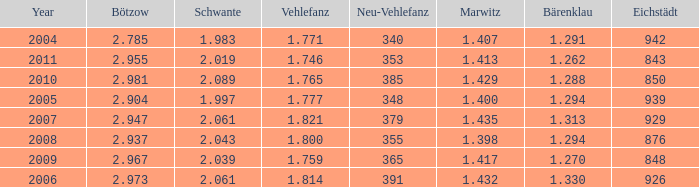What year has a Schwante smaller than 2.043, an Eichstädt smaller than 848, and a Bärenklau smaller than 1.262? 0.0. 